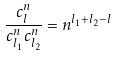Convert formula to latex. <formula><loc_0><loc_0><loc_500><loc_500>\frac { c _ { l } ^ { n } } { c _ { l _ { 1 } } ^ { n } c _ { l _ { 2 } } ^ { n } } = n ^ { l _ { 1 } + l _ { 2 } - l }</formula> 